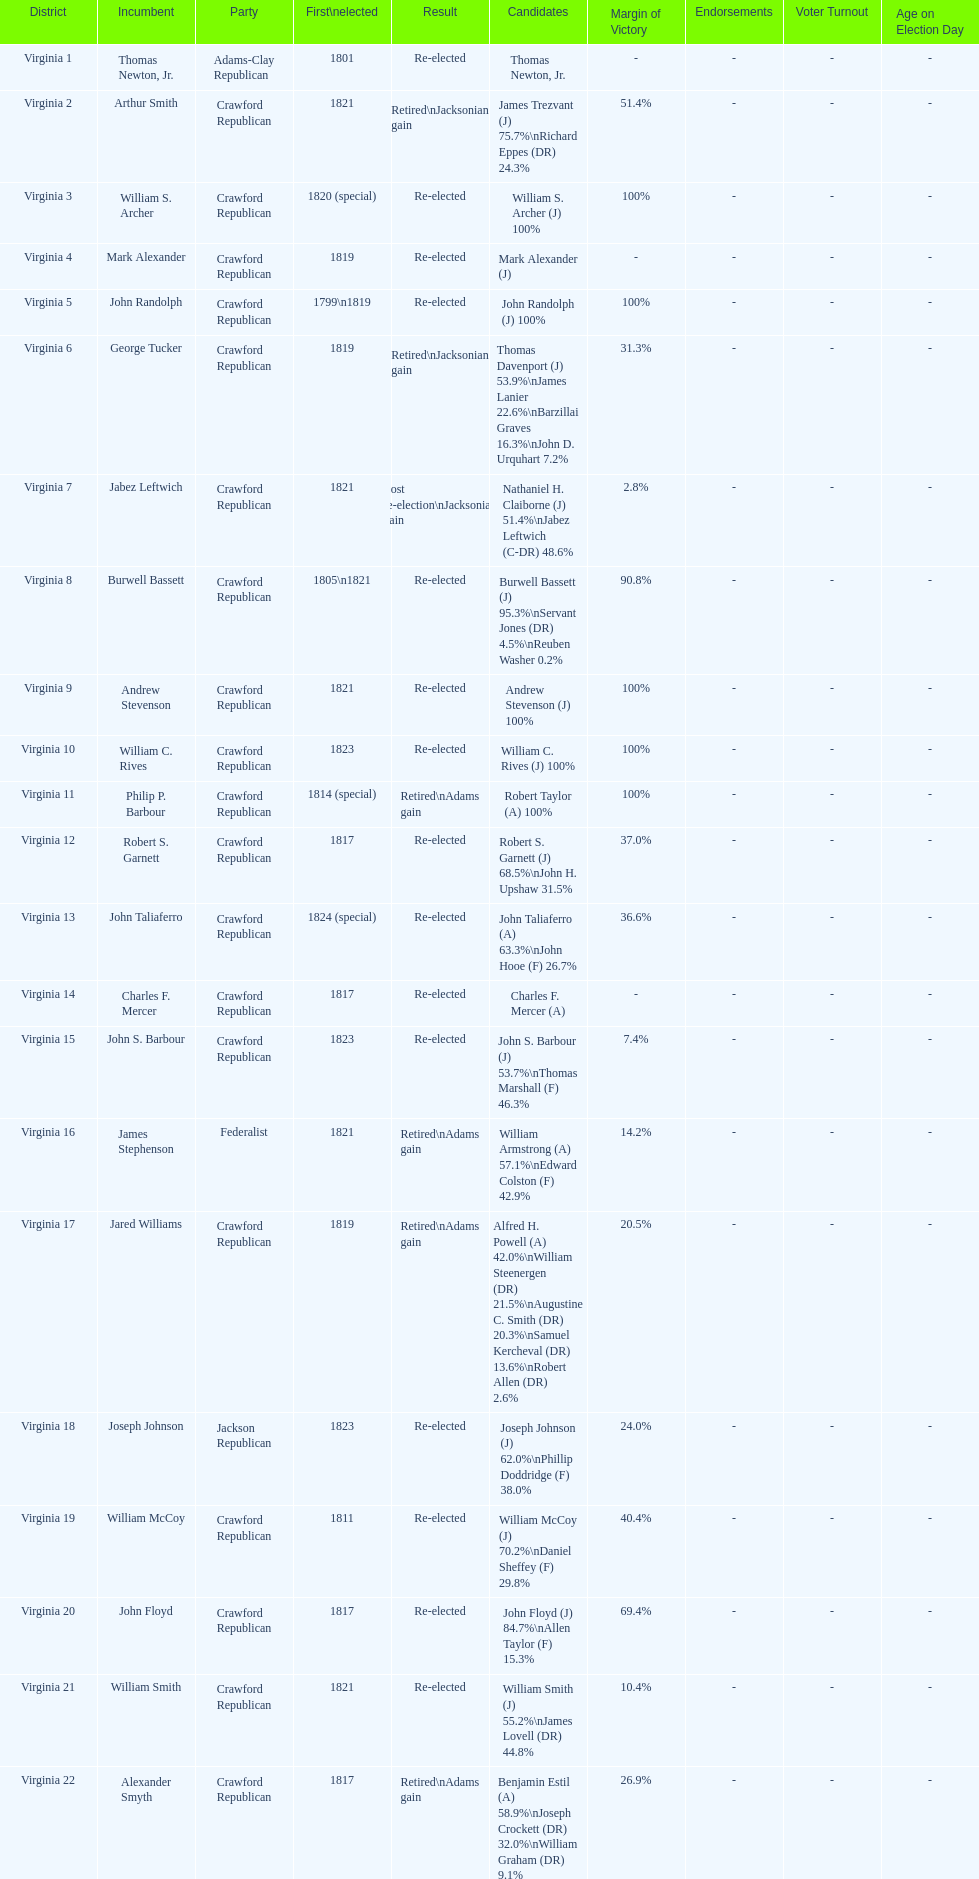Tell me the number of people first elected in 1817. 4. 